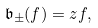<formula> <loc_0><loc_0><loc_500><loc_500>\mathfrak { b } _ { \pm } ( f ) = z f ,</formula> 